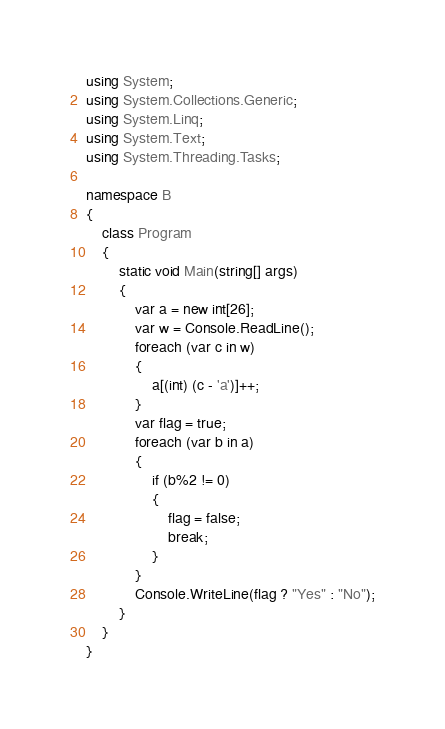<code> <loc_0><loc_0><loc_500><loc_500><_C#_>using System;
using System.Collections.Generic;
using System.Linq;
using System.Text;
using System.Threading.Tasks;

namespace B
{
    class Program
    {
        static void Main(string[] args)
        {
            var a = new int[26];
            var w = Console.ReadLine();
            foreach (var c in w)
            {
                a[(int) (c - 'a')]++;
            }
            var flag = true;
            foreach (var b in a)
            {
                if (b%2 != 0)
                {
                    flag = false;
                    break;
                }
            }
            Console.WriteLine(flag ? "Yes" : "No");
        }
    }
}
</code> 